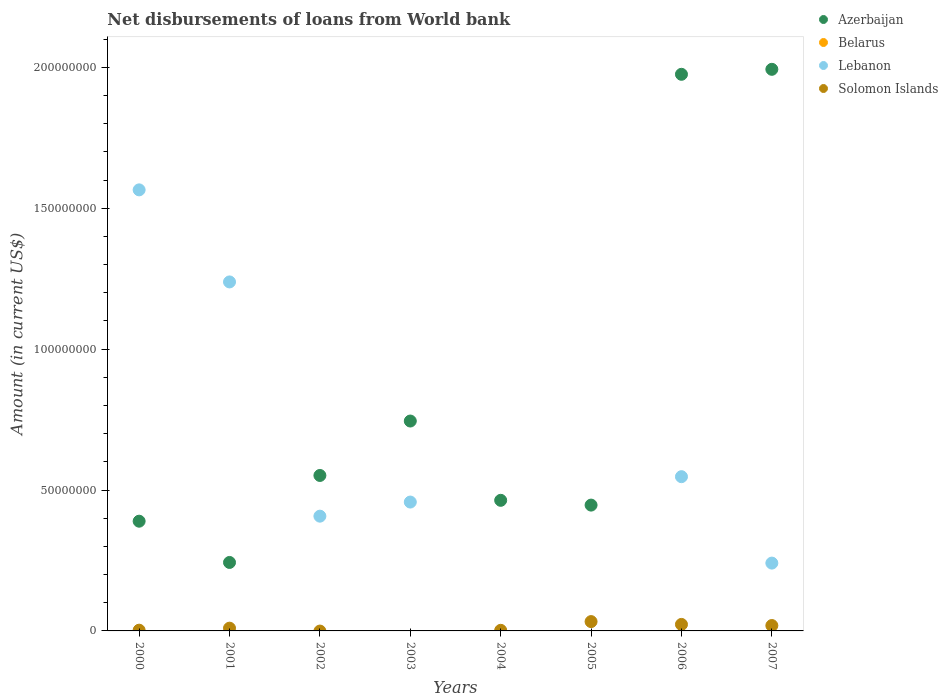How many different coloured dotlines are there?
Offer a very short reply. 3. Is the number of dotlines equal to the number of legend labels?
Offer a terse response. No. What is the amount of loan disbursed from World Bank in Solomon Islands in 2003?
Provide a succinct answer. 0. Across all years, what is the maximum amount of loan disbursed from World Bank in Azerbaijan?
Keep it short and to the point. 1.99e+08. In which year was the amount of loan disbursed from World Bank in Solomon Islands maximum?
Ensure brevity in your answer.  2005. What is the total amount of loan disbursed from World Bank in Solomon Islands in the graph?
Provide a short and direct response. 8.98e+06. What is the difference between the amount of loan disbursed from World Bank in Azerbaijan in 2004 and that in 2007?
Keep it short and to the point. -1.53e+08. What is the difference between the amount of loan disbursed from World Bank in Azerbaijan in 2006 and the amount of loan disbursed from World Bank in Belarus in 2000?
Give a very brief answer. 1.98e+08. What is the average amount of loan disbursed from World Bank in Lebanon per year?
Offer a very short reply. 5.57e+07. In the year 2000, what is the difference between the amount of loan disbursed from World Bank in Solomon Islands and amount of loan disbursed from World Bank in Lebanon?
Your answer should be compact. -1.56e+08. What is the ratio of the amount of loan disbursed from World Bank in Azerbaijan in 2000 to that in 2001?
Your response must be concise. 1.6. Is the amount of loan disbursed from World Bank in Lebanon in 2001 less than that in 2002?
Offer a terse response. No. What is the difference between the highest and the second highest amount of loan disbursed from World Bank in Azerbaijan?
Provide a succinct answer. 1.77e+06. What is the difference between the highest and the lowest amount of loan disbursed from World Bank in Azerbaijan?
Ensure brevity in your answer.  1.75e+08. In how many years, is the amount of loan disbursed from World Bank in Solomon Islands greater than the average amount of loan disbursed from World Bank in Solomon Islands taken over all years?
Offer a terse response. 3. Is the sum of the amount of loan disbursed from World Bank in Azerbaijan in 2003 and 2007 greater than the maximum amount of loan disbursed from World Bank in Lebanon across all years?
Ensure brevity in your answer.  Yes. Is it the case that in every year, the sum of the amount of loan disbursed from World Bank in Belarus and amount of loan disbursed from World Bank in Solomon Islands  is greater than the sum of amount of loan disbursed from World Bank in Azerbaijan and amount of loan disbursed from World Bank in Lebanon?
Give a very brief answer. No. Is it the case that in every year, the sum of the amount of loan disbursed from World Bank in Lebanon and amount of loan disbursed from World Bank in Azerbaijan  is greater than the amount of loan disbursed from World Bank in Belarus?
Offer a terse response. Yes. Does the amount of loan disbursed from World Bank in Azerbaijan monotonically increase over the years?
Make the answer very short. No. How many years are there in the graph?
Provide a succinct answer. 8. Does the graph contain grids?
Make the answer very short. No. How many legend labels are there?
Provide a succinct answer. 4. How are the legend labels stacked?
Your answer should be very brief. Vertical. What is the title of the graph?
Give a very brief answer. Net disbursements of loans from World bank. Does "Palau" appear as one of the legend labels in the graph?
Provide a succinct answer. No. What is the label or title of the X-axis?
Give a very brief answer. Years. What is the Amount (in current US$) of Azerbaijan in 2000?
Provide a short and direct response. 3.89e+07. What is the Amount (in current US$) in Lebanon in 2000?
Make the answer very short. 1.57e+08. What is the Amount (in current US$) of Solomon Islands in 2000?
Make the answer very short. 2.63e+05. What is the Amount (in current US$) in Azerbaijan in 2001?
Provide a succinct answer. 2.43e+07. What is the Amount (in current US$) in Belarus in 2001?
Your response must be concise. 0. What is the Amount (in current US$) of Lebanon in 2001?
Ensure brevity in your answer.  1.24e+08. What is the Amount (in current US$) of Solomon Islands in 2001?
Offer a terse response. 9.77e+05. What is the Amount (in current US$) in Azerbaijan in 2002?
Make the answer very short. 5.52e+07. What is the Amount (in current US$) in Lebanon in 2002?
Offer a terse response. 4.07e+07. What is the Amount (in current US$) in Solomon Islands in 2002?
Your answer should be very brief. 0. What is the Amount (in current US$) of Azerbaijan in 2003?
Your answer should be very brief. 7.45e+07. What is the Amount (in current US$) in Belarus in 2003?
Ensure brevity in your answer.  0. What is the Amount (in current US$) in Lebanon in 2003?
Ensure brevity in your answer.  4.57e+07. What is the Amount (in current US$) of Solomon Islands in 2003?
Your answer should be very brief. 0. What is the Amount (in current US$) in Azerbaijan in 2004?
Provide a succinct answer. 4.63e+07. What is the Amount (in current US$) in Solomon Islands in 2004?
Your response must be concise. 2.13e+05. What is the Amount (in current US$) in Azerbaijan in 2005?
Make the answer very short. 4.46e+07. What is the Amount (in current US$) in Lebanon in 2005?
Offer a terse response. 0. What is the Amount (in current US$) of Solomon Islands in 2005?
Ensure brevity in your answer.  3.31e+06. What is the Amount (in current US$) of Azerbaijan in 2006?
Your answer should be compact. 1.98e+08. What is the Amount (in current US$) in Belarus in 2006?
Provide a succinct answer. 0. What is the Amount (in current US$) of Lebanon in 2006?
Provide a succinct answer. 5.47e+07. What is the Amount (in current US$) in Solomon Islands in 2006?
Your response must be concise. 2.31e+06. What is the Amount (in current US$) of Azerbaijan in 2007?
Give a very brief answer. 1.99e+08. What is the Amount (in current US$) of Belarus in 2007?
Ensure brevity in your answer.  0. What is the Amount (in current US$) in Lebanon in 2007?
Provide a succinct answer. 2.41e+07. What is the Amount (in current US$) of Solomon Islands in 2007?
Give a very brief answer. 1.91e+06. Across all years, what is the maximum Amount (in current US$) of Azerbaijan?
Keep it short and to the point. 1.99e+08. Across all years, what is the maximum Amount (in current US$) in Lebanon?
Ensure brevity in your answer.  1.57e+08. Across all years, what is the maximum Amount (in current US$) of Solomon Islands?
Make the answer very short. 3.31e+06. Across all years, what is the minimum Amount (in current US$) of Azerbaijan?
Offer a very short reply. 2.43e+07. What is the total Amount (in current US$) in Azerbaijan in the graph?
Keep it short and to the point. 6.81e+08. What is the total Amount (in current US$) in Belarus in the graph?
Make the answer very short. 0. What is the total Amount (in current US$) in Lebanon in the graph?
Make the answer very short. 4.46e+08. What is the total Amount (in current US$) of Solomon Islands in the graph?
Your answer should be compact. 8.98e+06. What is the difference between the Amount (in current US$) of Azerbaijan in 2000 and that in 2001?
Your response must be concise. 1.46e+07. What is the difference between the Amount (in current US$) of Lebanon in 2000 and that in 2001?
Give a very brief answer. 3.27e+07. What is the difference between the Amount (in current US$) in Solomon Islands in 2000 and that in 2001?
Give a very brief answer. -7.14e+05. What is the difference between the Amount (in current US$) in Azerbaijan in 2000 and that in 2002?
Provide a short and direct response. -1.62e+07. What is the difference between the Amount (in current US$) of Lebanon in 2000 and that in 2002?
Keep it short and to the point. 1.16e+08. What is the difference between the Amount (in current US$) in Azerbaijan in 2000 and that in 2003?
Make the answer very short. -3.55e+07. What is the difference between the Amount (in current US$) of Lebanon in 2000 and that in 2003?
Ensure brevity in your answer.  1.11e+08. What is the difference between the Amount (in current US$) in Azerbaijan in 2000 and that in 2004?
Your response must be concise. -7.41e+06. What is the difference between the Amount (in current US$) in Solomon Islands in 2000 and that in 2004?
Give a very brief answer. 5.00e+04. What is the difference between the Amount (in current US$) of Azerbaijan in 2000 and that in 2005?
Your answer should be very brief. -5.71e+06. What is the difference between the Amount (in current US$) of Solomon Islands in 2000 and that in 2005?
Make the answer very short. -3.05e+06. What is the difference between the Amount (in current US$) of Azerbaijan in 2000 and that in 2006?
Your answer should be very brief. -1.59e+08. What is the difference between the Amount (in current US$) of Lebanon in 2000 and that in 2006?
Provide a short and direct response. 1.02e+08. What is the difference between the Amount (in current US$) in Solomon Islands in 2000 and that in 2006?
Make the answer very short. -2.05e+06. What is the difference between the Amount (in current US$) of Azerbaijan in 2000 and that in 2007?
Keep it short and to the point. -1.60e+08. What is the difference between the Amount (in current US$) in Lebanon in 2000 and that in 2007?
Provide a succinct answer. 1.32e+08. What is the difference between the Amount (in current US$) of Solomon Islands in 2000 and that in 2007?
Provide a short and direct response. -1.65e+06. What is the difference between the Amount (in current US$) in Azerbaijan in 2001 and that in 2002?
Give a very brief answer. -3.09e+07. What is the difference between the Amount (in current US$) of Lebanon in 2001 and that in 2002?
Make the answer very short. 8.31e+07. What is the difference between the Amount (in current US$) of Azerbaijan in 2001 and that in 2003?
Ensure brevity in your answer.  -5.02e+07. What is the difference between the Amount (in current US$) of Lebanon in 2001 and that in 2003?
Ensure brevity in your answer.  7.81e+07. What is the difference between the Amount (in current US$) in Azerbaijan in 2001 and that in 2004?
Your answer should be very brief. -2.20e+07. What is the difference between the Amount (in current US$) in Solomon Islands in 2001 and that in 2004?
Give a very brief answer. 7.64e+05. What is the difference between the Amount (in current US$) in Azerbaijan in 2001 and that in 2005?
Your answer should be compact. -2.04e+07. What is the difference between the Amount (in current US$) in Solomon Islands in 2001 and that in 2005?
Your answer should be compact. -2.33e+06. What is the difference between the Amount (in current US$) of Azerbaijan in 2001 and that in 2006?
Ensure brevity in your answer.  -1.73e+08. What is the difference between the Amount (in current US$) in Lebanon in 2001 and that in 2006?
Make the answer very short. 6.91e+07. What is the difference between the Amount (in current US$) in Solomon Islands in 2001 and that in 2006?
Provide a short and direct response. -1.33e+06. What is the difference between the Amount (in current US$) in Azerbaijan in 2001 and that in 2007?
Keep it short and to the point. -1.75e+08. What is the difference between the Amount (in current US$) of Lebanon in 2001 and that in 2007?
Offer a terse response. 9.98e+07. What is the difference between the Amount (in current US$) of Solomon Islands in 2001 and that in 2007?
Your answer should be compact. -9.33e+05. What is the difference between the Amount (in current US$) in Azerbaijan in 2002 and that in 2003?
Provide a short and direct response. -1.93e+07. What is the difference between the Amount (in current US$) in Lebanon in 2002 and that in 2003?
Offer a terse response. -5.01e+06. What is the difference between the Amount (in current US$) of Azerbaijan in 2002 and that in 2004?
Give a very brief answer. 8.82e+06. What is the difference between the Amount (in current US$) of Azerbaijan in 2002 and that in 2005?
Ensure brevity in your answer.  1.05e+07. What is the difference between the Amount (in current US$) of Azerbaijan in 2002 and that in 2006?
Ensure brevity in your answer.  -1.42e+08. What is the difference between the Amount (in current US$) in Lebanon in 2002 and that in 2006?
Offer a terse response. -1.40e+07. What is the difference between the Amount (in current US$) of Azerbaijan in 2002 and that in 2007?
Give a very brief answer. -1.44e+08. What is the difference between the Amount (in current US$) of Lebanon in 2002 and that in 2007?
Make the answer very short. 1.67e+07. What is the difference between the Amount (in current US$) in Azerbaijan in 2003 and that in 2004?
Provide a short and direct response. 2.81e+07. What is the difference between the Amount (in current US$) in Azerbaijan in 2003 and that in 2005?
Provide a succinct answer. 2.98e+07. What is the difference between the Amount (in current US$) in Azerbaijan in 2003 and that in 2006?
Ensure brevity in your answer.  -1.23e+08. What is the difference between the Amount (in current US$) of Lebanon in 2003 and that in 2006?
Your response must be concise. -9.01e+06. What is the difference between the Amount (in current US$) in Azerbaijan in 2003 and that in 2007?
Make the answer very short. -1.25e+08. What is the difference between the Amount (in current US$) in Lebanon in 2003 and that in 2007?
Provide a succinct answer. 2.17e+07. What is the difference between the Amount (in current US$) of Azerbaijan in 2004 and that in 2005?
Keep it short and to the point. 1.70e+06. What is the difference between the Amount (in current US$) in Solomon Islands in 2004 and that in 2005?
Give a very brief answer. -3.10e+06. What is the difference between the Amount (in current US$) in Azerbaijan in 2004 and that in 2006?
Your response must be concise. -1.51e+08. What is the difference between the Amount (in current US$) in Solomon Islands in 2004 and that in 2006?
Give a very brief answer. -2.10e+06. What is the difference between the Amount (in current US$) of Azerbaijan in 2004 and that in 2007?
Ensure brevity in your answer.  -1.53e+08. What is the difference between the Amount (in current US$) of Solomon Islands in 2004 and that in 2007?
Your response must be concise. -1.70e+06. What is the difference between the Amount (in current US$) of Azerbaijan in 2005 and that in 2006?
Give a very brief answer. -1.53e+08. What is the difference between the Amount (in current US$) in Solomon Islands in 2005 and that in 2006?
Your answer should be compact. 9.98e+05. What is the difference between the Amount (in current US$) in Azerbaijan in 2005 and that in 2007?
Offer a very short reply. -1.55e+08. What is the difference between the Amount (in current US$) in Solomon Islands in 2005 and that in 2007?
Ensure brevity in your answer.  1.40e+06. What is the difference between the Amount (in current US$) in Azerbaijan in 2006 and that in 2007?
Give a very brief answer. -1.77e+06. What is the difference between the Amount (in current US$) of Lebanon in 2006 and that in 2007?
Offer a terse response. 3.07e+07. What is the difference between the Amount (in current US$) of Solomon Islands in 2006 and that in 2007?
Your answer should be compact. 4.01e+05. What is the difference between the Amount (in current US$) in Azerbaijan in 2000 and the Amount (in current US$) in Lebanon in 2001?
Offer a very short reply. -8.49e+07. What is the difference between the Amount (in current US$) in Azerbaijan in 2000 and the Amount (in current US$) in Solomon Islands in 2001?
Give a very brief answer. 3.80e+07. What is the difference between the Amount (in current US$) of Lebanon in 2000 and the Amount (in current US$) of Solomon Islands in 2001?
Offer a very short reply. 1.56e+08. What is the difference between the Amount (in current US$) of Azerbaijan in 2000 and the Amount (in current US$) of Lebanon in 2002?
Your answer should be compact. -1.78e+06. What is the difference between the Amount (in current US$) in Azerbaijan in 2000 and the Amount (in current US$) in Lebanon in 2003?
Keep it short and to the point. -6.79e+06. What is the difference between the Amount (in current US$) in Azerbaijan in 2000 and the Amount (in current US$) in Solomon Islands in 2004?
Your answer should be very brief. 3.87e+07. What is the difference between the Amount (in current US$) in Lebanon in 2000 and the Amount (in current US$) in Solomon Islands in 2004?
Provide a succinct answer. 1.56e+08. What is the difference between the Amount (in current US$) in Azerbaijan in 2000 and the Amount (in current US$) in Solomon Islands in 2005?
Offer a very short reply. 3.56e+07. What is the difference between the Amount (in current US$) of Lebanon in 2000 and the Amount (in current US$) of Solomon Islands in 2005?
Your answer should be very brief. 1.53e+08. What is the difference between the Amount (in current US$) in Azerbaijan in 2000 and the Amount (in current US$) in Lebanon in 2006?
Give a very brief answer. -1.58e+07. What is the difference between the Amount (in current US$) of Azerbaijan in 2000 and the Amount (in current US$) of Solomon Islands in 2006?
Ensure brevity in your answer.  3.66e+07. What is the difference between the Amount (in current US$) in Lebanon in 2000 and the Amount (in current US$) in Solomon Islands in 2006?
Provide a short and direct response. 1.54e+08. What is the difference between the Amount (in current US$) of Azerbaijan in 2000 and the Amount (in current US$) of Lebanon in 2007?
Provide a short and direct response. 1.49e+07. What is the difference between the Amount (in current US$) in Azerbaijan in 2000 and the Amount (in current US$) in Solomon Islands in 2007?
Provide a succinct answer. 3.70e+07. What is the difference between the Amount (in current US$) of Lebanon in 2000 and the Amount (in current US$) of Solomon Islands in 2007?
Your response must be concise. 1.55e+08. What is the difference between the Amount (in current US$) of Azerbaijan in 2001 and the Amount (in current US$) of Lebanon in 2002?
Provide a short and direct response. -1.64e+07. What is the difference between the Amount (in current US$) of Azerbaijan in 2001 and the Amount (in current US$) of Lebanon in 2003?
Ensure brevity in your answer.  -2.14e+07. What is the difference between the Amount (in current US$) of Azerbaijan in 2001 and the Amount (in current US$) of Solomon Islands in 2004?
Offer a very short reply. 2.41e+07. What is the difference between the Amount (in current US$) of Lebanon in 2001 and the Amount (in current US$) of Solomon Islands in 2004?
Ensure brevity in your answer.  1.24e+08. What is the difference between the Amount (in current US$) of Azerbaijan in 2001 and the Amount (in current US$) of Solomon Islands in 2005?
Ensure brevity in your answer.  2.10e+07. What is the difference between the Amount (in current US$) of Lebanon in 2001 and the Amount (in current US$) of Solomon Islands in 2005?
Offer a very short reply. 1.21e+08. What is the difference between the Amount (in current US$) of Azerbaijan in 2001 and the Amount (in current US$) of Lebanon in 2006?
Offer a very short reply. -3.04e+07. What is the difference between the Amount (in current US$) of Azerbaijan in 2001 and the Amount (in current US$) of Solomon Islands in 2006?
Your answer should be compact. 2.20e+07. What is the difference between the Amount (in current US$) in Lebanon in 2001 and the Amount (in current US$) in Solomon Islands in 2006?
Your answer should be very brief. 1.22e+08. What is the difference between the Amount (in current US$) of Azerbaijan in 2001 and the Amount (in current US$) of Lebanon in 2007?
Offer a very short reply. 2.29e+05. What is the difference between the Amount (in current US$) of Azerbaijan in 2001 and the Amount (in current US$) of Solomon Islands in 2007?
Ensure brevity in your answer.  2.24e+07. What is the difference between the Amount (in current US$) of Lebanon in 2001 and the Amount (in current US$) of Solomon Islands in 2007?
Give a very brief answer. 1.22e+08. What is the difference between the Amount (in current US$) of Azerbaijan in 2002 and the Amount (in current US$) of Lebanon in 2003?
Give a very brief answer. 9.44e+06. What is the difference between the Amount (in current US$) of Azerbaijan in 2002 and the Amount (in current US$) of Solomon Islands in 2004?
Ensure brevity in your answer.  5.50e+07. What is the difference between the Amount (in current US$) in Lebanon in 2002 and the Amount (in current US$) in Solomon Islands in 2004?
Offer a terse response. 4.05e+07. What is the difference between the Amount (in current US$) in Azerbaijan in 2002 and the Amount (in current US$) in Solomon Islands in 2005?
Ensure brevity in your answer.  5.19e+07. What is the difference between the Amount (in current US$) of Lebanon in 2002 and the Amount (in current US$) of Solomon Islands in 2005?
Keep it short and to the point. 3.74e+07. What is the difference between the Amount (in current US$) of Azerbaijan in 2002 and the Amount (in current US$) of Lebanon in 2006?
Offer a terse response. 4.30e+05. What is the difference between the Amount (in current US$) in Azerbaijan in 2002 and the Amount (in current US$) in Solomon Islands in 2006?
Your answer should be very brief. 5.29e+07. What is the difference between the Amount (in current US$) of Lebanon in 2002 and the Amount (in current US$) of Solomon Islands in 2006?
Keep it short and to the point. 3.84e+07. What is the difference between the Amount (in current US$) in Azerbaijan in 2002 and the Amount (in current US$) in Lebanon in 2007?
Give a very brief answer. 3.11e+07. What is the difference between the Amount (in current US$) in Azerbaijan in 2002 and the Amount (in current US$) in Solomon Islands in 2007?
Provide a short and direct response. 5.33e+07. What is the difference between the Amount (in current US$) in Lebanon in 2002 and the Amount (in current US$) in Solomon Islands in 2007?
Give a very brief answer. 3.88e+07. What is the difference between the Amount (in current US$) of Azerbaijan in 2003 and the Amount (in current US$) of Solomon Islands in 2004?
Your answer should be compact. 7.43e+07. What is the difference between the Amount (in current US$) of Lebanon in 2003 and the Amount (in current US$) of Solomon Islands in 2004?
Make the answer very short. 4.55e+07. What is the difference between the Amount (in current US$) in Azerbaijan in 2003 and the Amount (in current US$) in Solomon Islands in 2005?
Keep it short and to the point. 7.12e+07. What is the difference between the Amount (in current US$) of Lebanon in 2003 and the Amount (in current US$) of Solomon Islands in 2005?
Your answer should be very brief. 4.24e+07. What is the difference between the Amount (in current US$) in Azerbaijan in 2003 and the Amount (in current US$) in Lebanon in 2006?
Offer a terse response. 1.97e+07. What is the difference between the Amount (in current US$) of Azerbaijan in 2003 and the Amount (in current US$) of Solomon Islands in 2006?
Give a very brief answer. 7.22e+07. What is the difference between the Amount (in current US$) in Lebanon in 2003 and the Amount (in current US$) in Solomon Islands in 2006?
Your answer should be very brief. 4.34e+07. What is the difference between the Amount (in current US$) of Azerbaijan in 2003 and the Amount (in current US$) of Lebanon in 2007?
Your response must be concise. 5.04e+07. What is the difference between the Amount (in current US$) of Azerbaijan in 2003 and the Amount (in current US$) of Solomon Islands in 2007?
Offer a very short reply. 7.26e+07. What is the difference between the Amount (in current US$) of Lebanon in 2003 and the Amount (in current US$) of Solomon Islands in 2007?
Your response must be concise. 4.38e+07. What is the difference between the Amount (in current US$) of Azerbaijan in 2004 and the Amount (in current US$) of Solomon Islands in 2005?
Your response must be concise. 4.30e+07. What is the difference between the Amount (in current US$) of Azerbaijan in 2004 and the Amount (in current US$) of Lebanon in 2006?
Your answer should be compact. -8.39e+06. What is the difference between the Amount (in current US$) in Azerbaijan in 2004 and the Amount (in current US$) in Solomon Islands in 2006?
Offer a terse response. 4.40e+07. What is the difference between the Amount (in current US$) in Azerbaijan in 2004 and the Amount (in current US$) in Lebanon in 2007?
Give a very brief answer. 2.23e+07. What is the difference between the Amount (in current US$) in Azerbaijan in 2004 and the Amount (in current US$) in Solomon Islands in 2007?
Provide a succinct answer. 4.44e+07. What is the difference between the Amount (in current US$) of Azerbaijan in 2005 and the Amount (in current US$) of Lebanon in 2006?
Make the answer very short. -1.01e+07. What is the difference between the Amount (in current US$) of Azerbaijan in 2005 and the Amount (in current US$) of Solomon Islands in 2006?
Offer a very short reply. 4.23e+07. What is the difference between the Amount (in current US$) of Azerbaijan in 2005 and the Amount (in current US$) of Lebanon in 2007?
Your response must be concise. 2.06e+07. What is the difference between the Amount (in current US$) of Azerbaijan in 2005 and the Amount (in current US$) of Solomon Islands in 2007?
Offer a terse response. 4.27e+07. What is the difference between the Amount (in current US$) in Azerbaijan in 2006 and the Amount (in current US$) in Lebanon in 2007?
Offer a very short reply. 1.73e+08. What is the difference between the Amount (in current US$) in Azerbaijan in 2006 and the Amount (in current US$) in Solomon Islands in 2007?
Ensure brevity in your answer.  1.96e+08. What is the difference between the Amount (in current US$) in Lebanon in 2006 and the Amount (in current US$) in Solomon Islands in 2007?
Provide a short and direct response. 5.28e+07. What is the average Amount (in current US$) in Azerbaijan per year?
Your answer should be very brief. 8.51e+07. What is the average Amount (in current US$) in Lebanon per year?
Provide a short and direct response. 5.57e+07. What is the average Amount (in current US$) of Solomon Islands per year?
Your answer should be very brief. 1.12e+06. In the year 2000, what is the difference between the Amount (in current US$) in Azerbaijan and Amount (in current US$) in Lebanon?
Your response must be concise. -1.18e+08. In the year 2000, what is the difference between the Amount (in current US$) in Azerbaijan and Amount (in current US$) in Solomon Islands?
Give a very brief answer. 3.87e+07. In the year 2000, what is the difference between the Amount (in current US$) in Lebanon and Amount (in current US$) in Solomon Islands?
Your answer should be very brief. 1.56e+08. In the year 2001, what is the difference between the Amount (in current US$) in Azerbaijan and Amount (in current US$) in Lebanon?
Offer a terse response. -9.95e+07. In the year 2001, what is the difference between the Amount (in current US$) of Azerbaijan and Amount (in current US$) of Solomon Islands?
Provide a succinct answer. 2.33e+07. In the year 2001, what is the difference between the Amount (in current US$) in Lebanon and Amount (in current US$) in Solomon Islands?
Your answer should be very brief. 1.23e+08. In the year 2002, what is the difference between the Amount (in current US$) of Azerbaijan and Amount (in current US$) of Lebanon?
Ensure brevity in your answer.  1.44e+07. In the year 2003, what is the difference between the Amount (in current US$) in Azerbaijan and Amount (in current US$) in Lebanon?
Provide a succinct answer. 2.88e+07. In the year 2004, what is the difference between the Amount (in current US$) of Azerbaijan and Amount (in current US$) of Solomon Islands?
Offer a very short reply. 4.61e+07. In the year 2005, what is the difference between the Amount (in current US$) in Azerbaijan and Amount (in current US$) in Solomon Islands?
Offer a terse response. 4.13e+07. In the year 2006, what is the difference between the Amount (in current US$) of Azerbaijan and Amount (in current US$) of Lebanon?
Provide a succinct answer. 1.43e+08. In the year 2006, what is the difference between the Amount (in current US$) in Azerbaijan and Amount (in current US$) in Solomon Islands?
Provide a succinct answer. 1.95e+08. In the year 2006, what is the difference between the Amount (in current US$) of Lebanon and Amount (in current US$) of Solomon Islands?
Ensure brevity in your answer.  5.24e+07. In the year 2007, what is the difference between the Amount (in current US$) in Azerbaijan and Amount (in current US$) in Lebanon?
Offer a very short reply. 1.75e+08. In the year 2007, what is the difference between the Amount (in current US$) of Azerbaijan and Amount (in current US$) of Solomon Islands?
Provide a succinct answer. 1.97e+08. In the year 2007, what is the difference between the Amount (in current US$) in Lebanon and Amount (in current US$) in Solomon Islands?
Give a very brief answer. 2.22e+07. What is the ratio of the Amount (in current US$) of Azerbaijan in 2000 to that in 2001?
Provide a succinct answer. 1.6. What is the ratio of the Amount (in current US$) in Lebanon in 2000 to that in 2001?
Provide a short and direct response. 1.26. What is the ratio of the Amount (in current US$) in Solomon Islands in 2000 to that in 2001?
Make the answer very short. 0.27. What is the ratio of the Amount (in current US$) in Azerbaijan in 2000 to that in 2002?
Your response must be concise. 0.71. What is the ratio of the Amount (in current US$) in Lebanon in 2000 to that in 2002?
Your response must be concise. 3.84. What is the ratio of the Amount (in current US$) of Azerbaijan in 2000 to that in 2003?
Offer a terse response. 0.52. What is the ratio of the Amount (in current US$) in Lebanon in 2000 to that in 2003?
Your answer should be compact. 3.42. What is the ratio of the Amount (in current US$) in Azerbaijan in 2000 to that in 2004?
Offer a terse response. 0.84. What is the ratio of the Amount (in current US$) in Solomon Islands in 2000 to that in 2004?
Provide a succinct answer. 1.23. What is the ratio of the Amount (in current US$) in Azerbaijan in 2000 to that in 2005?
Give a very brief answer. 0.87. What is the ratio of the Amount (in current US$) in Solomon Islands in 2000 to that in 2005?
Offer a terse response. 0.08. What is the ratio of the Amount (in current US$) in Azerbaijan in 2000 to that in 2006?
Offer a terse response. 0.2. What is the ratio of the Amount (in current US$) in Lebanon in 2000 to that in 2006?
Offer a terse response. 2.86. What is the ratio of the Amount (in current US$) of Solomon Islands in 2000 to that in 2006?
Ensure brevity in your answer.  0.11. What is the ratio of the Amount (in current US$) of Azerbaijan in 2000 to that in 2007?
Make the answer very short. 0.2. What is the ratio of the Amount (in current US$) of Lebanon in 2000 to that in 2007?
Your answer should be very brief. 6.5. What is the ratio of the Amount (in current US$) in Solomon Islands in 2000 to that in 2007?
Provide a succinct answer. 0.14. What is the ratio of the Amount (in current US$) of Azerbaijan in 2001 to that in 2002?
Keep it short and to the point. 0.44. What is the ratio of the Amount (in current US$) of Lebanon in 2001 to that in 2002?
Your answer should be compact. 3.04. What is the ratio of the Amount (in current US$) of Azerbaijan in 2001 to that in 2003?
Offer a terse response. 0.33. What is the ratio of the Amount (in current US$) of Lebanon in 2001 to that in 2003?
Your answer should be compact. 2.71. What is the ratio of the Amount (in current US$) of Azerbaijan in 2001 to that in 2004?
Your answer should be very brief. 0.52. What is the ratio of the Amount (in current US$) in Solomon Islands in 2001 to that in 2004?
Your response must be concise. 4.59. What is the ratio of the Amount (in current US$) in Azerbaijan in 2001 to that in 2005?
Offer a very short reply. 0.54. What is the ratio of the Amount (in current US$) of Solomon Islands in 2001 to that in 2005?
Give a very brief answer. 0.3. What is the ratio of the Amount (in current US$) in Azerbaijan in 2001 to that in 2006?
Your answer should be very brief. 0.12. What is the ratio of the Amount (in current US$) of Lebanon in 2001 to that in 2006?
Provide a succinct answer. 2.26. What is the ratio of the Amount (in current US$) in Solomon Islands in 2001 to that in 2006?
Offer a terse response. 0.42. What is the ratio of the Amount (in current US$) of Azerbaijan in 2001 to that in 2007?
Offer a very short reply. 0.12. What is the ratio of the Amount (in current US$) of Lebanon in 2001 to that in 2007?
Your response must be concise. 5.15. What is the ratio of the Amount (in current US$) in Solomon Islands in 2001 to that in 2007?
Your answer should be compact. 0.51. What is the ratio of the Amount (in current US$) of Azerbaijan in 2002 to that in 2003?
Keep it short and to the point. 0.74. What is the ratio of the Amount (in current US$) of Lebanon in 2002 to that in 2003?
Give a very brief answer. 0.89. What is the ratio of the Amount (in current US$) of Azerbaijan in 2002 to that in 2004?
Keep it short and to the point. 1.19. What is the ratio of the Amount (in current US$) in Azerbaijan in 2002 to that in 2005?
Make the answer very short. 1.24. What is the ratio of the Amount (in current US$) of Azerbaijan in 2002 to that in 2006?
Offer a very short reply. 0.28. What is the ratio of the Amount (in current US$) of Lebanon in 2002 to that in 2006?
Offer a terse response. 0.74. What is the ratio of the Amount (in current US$) in Azerbaijan in 2002 to that in 2007?
Your answer should be very brief. 0.28. What is the ratio of the Amount (in current US$) of Lebanon in 2002 to that in 2007?
Your answer should be compact. 1.69. What is the ratio of the Amount (in current US$) in Azerbaijan in 2003 to that in 2004?
Give a very brief answer. 1.61. What is the ratio of the Amount (in current US$) of Azerbaijan in 2003 to that in 2005?
Your answer should be very brief. 1.67. What is the ratio of the Amount (in current US$) in Azerbaijan in 2003 to that in 2006?
Give a very brief answer. 0.38. What is the ratio of the Amount (in current US$) in Lebanon in 2003 to that in 2006?
Your answer should be very brief. 0.84. What is the ratio of the Amount (in current US$) in Azerbaijan in 2003 to that in 2007?
Keep it short and to the point. 0.37. What is the ratio of the Amount (in current US$) in Lebanon in 2003 to that in 2007?
Your answer should be very brief. 1.9. What is the ratio of the Amount (in current US$) of Azerbaijan in 2004 to that in 2005?
Your answer should be very brief. 1.04. What is the ratio of the Amount (in current US$) of Solomon Islands in 2004 to that in 2005?
Make the answer very short. 0.06. What is the ratio of the Amount (in current US$) of Azerbaijan in 2004 to that in 2006?
Your response must be concise. 0.23. What is the ratio of the Amount (in current US$) of Solomon Islands in 2004 to that in 2006?
Offer a very short reply. 0.09. What is the ratio of the Amount (in current US$) in Azerbaijan in 2004 to that in 2007?
Offer a terse response. 0.23. What is the ratio of the Amount (in current US$) of Solomon Islands in 2004 to that in 2007?
Offer a terse response. 0.11. What is the ratio of the Amount (in current US$) of Azerbaijan in 2005 to that in 2006?
Your answer should be compact. 0.23. What is the ratio of the Amount (in current US$) in Solomon Islands in 2005 to that in 2006?
Your answer should be compact. 1.43. What is the ratio of the Amount (in current US$) of Azerbaijan in 2005 to that in 2007?
Your response must be concise. 0.22. What is the ratio of the Amount (in current US$) of Solomon Islands in 2005 to that in 2007?
Offer a terse response. 1.73. What is the ratio of the Amount (in current US$) in Azerbaijan in 2006 to that in 2007?
Offer a very short reply. 0.99. What is the ratio of the Amount (in current US$) of Lebanon in 2006 to that in 2007?
Your response must be concise. 2.27. What is the ratio of the Amount (in current US$) of Solomon Islands in 2006 to that in 2007?
Offer a very short reply. 1.21. What is the difference between the highest and the second highest Amount (in current US$) of Azerbaijan?
Ensure brevity in your answer.  1.77e+06. What is the difference between the highest and the second highest Amount (in current US$) in Lebanon?
Offer a terse response. 3.27e+07. What is the difference between the highest and the second highest Amount (in current US$) of Solomon Islands?
Offer a terse response. 9.98e+05. What is the difference between the highest and the lowest Amount (in current US$) in Azerbaijan?
Provide a short and direct response. 1.75e+08. What is the difference between the highest and the lowest Amount (in current US$) of Lebanon?
Provide a succinct answer. 1.57e+08. What is the difference between the highest and the lowest Amount (in current US$) in Solomon Islands?
Keep it short and to the point. 3.31e+06. 